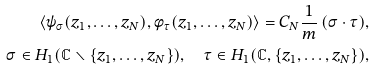Convert formula to latex. <formula><loc_0><loc_0><loc_500><loc_500>\langle \psi _ { \sigma } ( z _ { 1 } , \dots , z _ { N } ) , \phi _ { \tau } ( z _ { 1 } , \dots , z _ { N } ) \rangle = C _ { N } \frac { 1 } { m } \, ( \sigma \cdot \tau ) , \\ \sigma \in H _ { 1 } ( \mathbb { C } \smallsetminus \{ z _ { 1 } , \dots , z _ { N } \} ) , \quad \tau \in H _ { 1 } ( \mathbb { C } , \{ z _ { 1 } , \dots , z _ { N } \} ) ,</formula> 